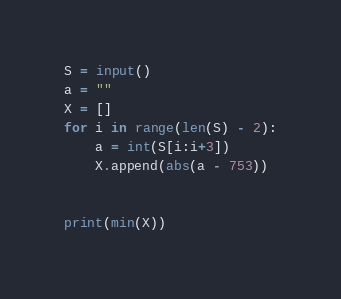Convert code to text. <code><loc_0><loc_0><loc_500><loc_500><_Python_>S = input()
a = ""
X = []
for i in range(len(S) - 2):
    a = int(S[i:i+3])
    X.append(abs(a - 753))


print(min(X))</code> 